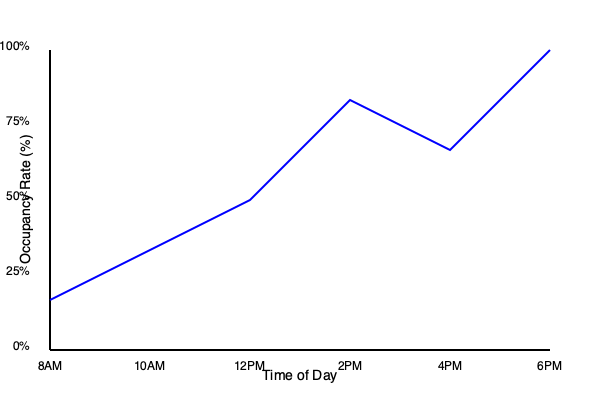Based on the parking occupancy rate graph, during which time period would you have the best chance of finding an available parking spot on campus? To determine the best time to find an available parking spot, we need to identify the period with the lowest occupancy rate. Let's analyze the graph step-by-step:

1. The graph shows parking occupancy rates from 8AM to 6PM.
2. The y-axis represents the occupancy rate from 0% to 100%.
3. The line on the graph represents how the occupancy rate changes over time.
4. We need to find the lowest point on the line, which indicates the lowest occupancy rate.

Examining the graph:
- 8AM: Occupancy is around 25%
- 10AM: Occupancy increases to about 40%
- 12PM: Occupancy continues to rise to approximately 50%
- 2PM: Occupancy reaches its peak at about 80%
- 4PM: Occupancy decreases to around 65%
- 6PM: Occupancy drops significantly to about 90%

The lowest point on the graph is at 8AM, with an occupancy rate of approximately 25%. This means that 75% of parking spots are likely to be available at this time.

Therefore, you would have the best chance of finding an available parking spot at 8AM.
Answer: 8AM 